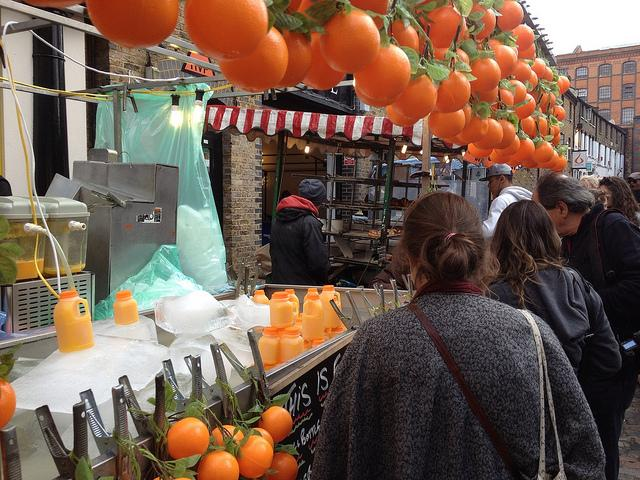The orange orbs seen here are actually what?

Choices:
A) real oranges
B) plastic
C) lemons
D) pinatas plastic 